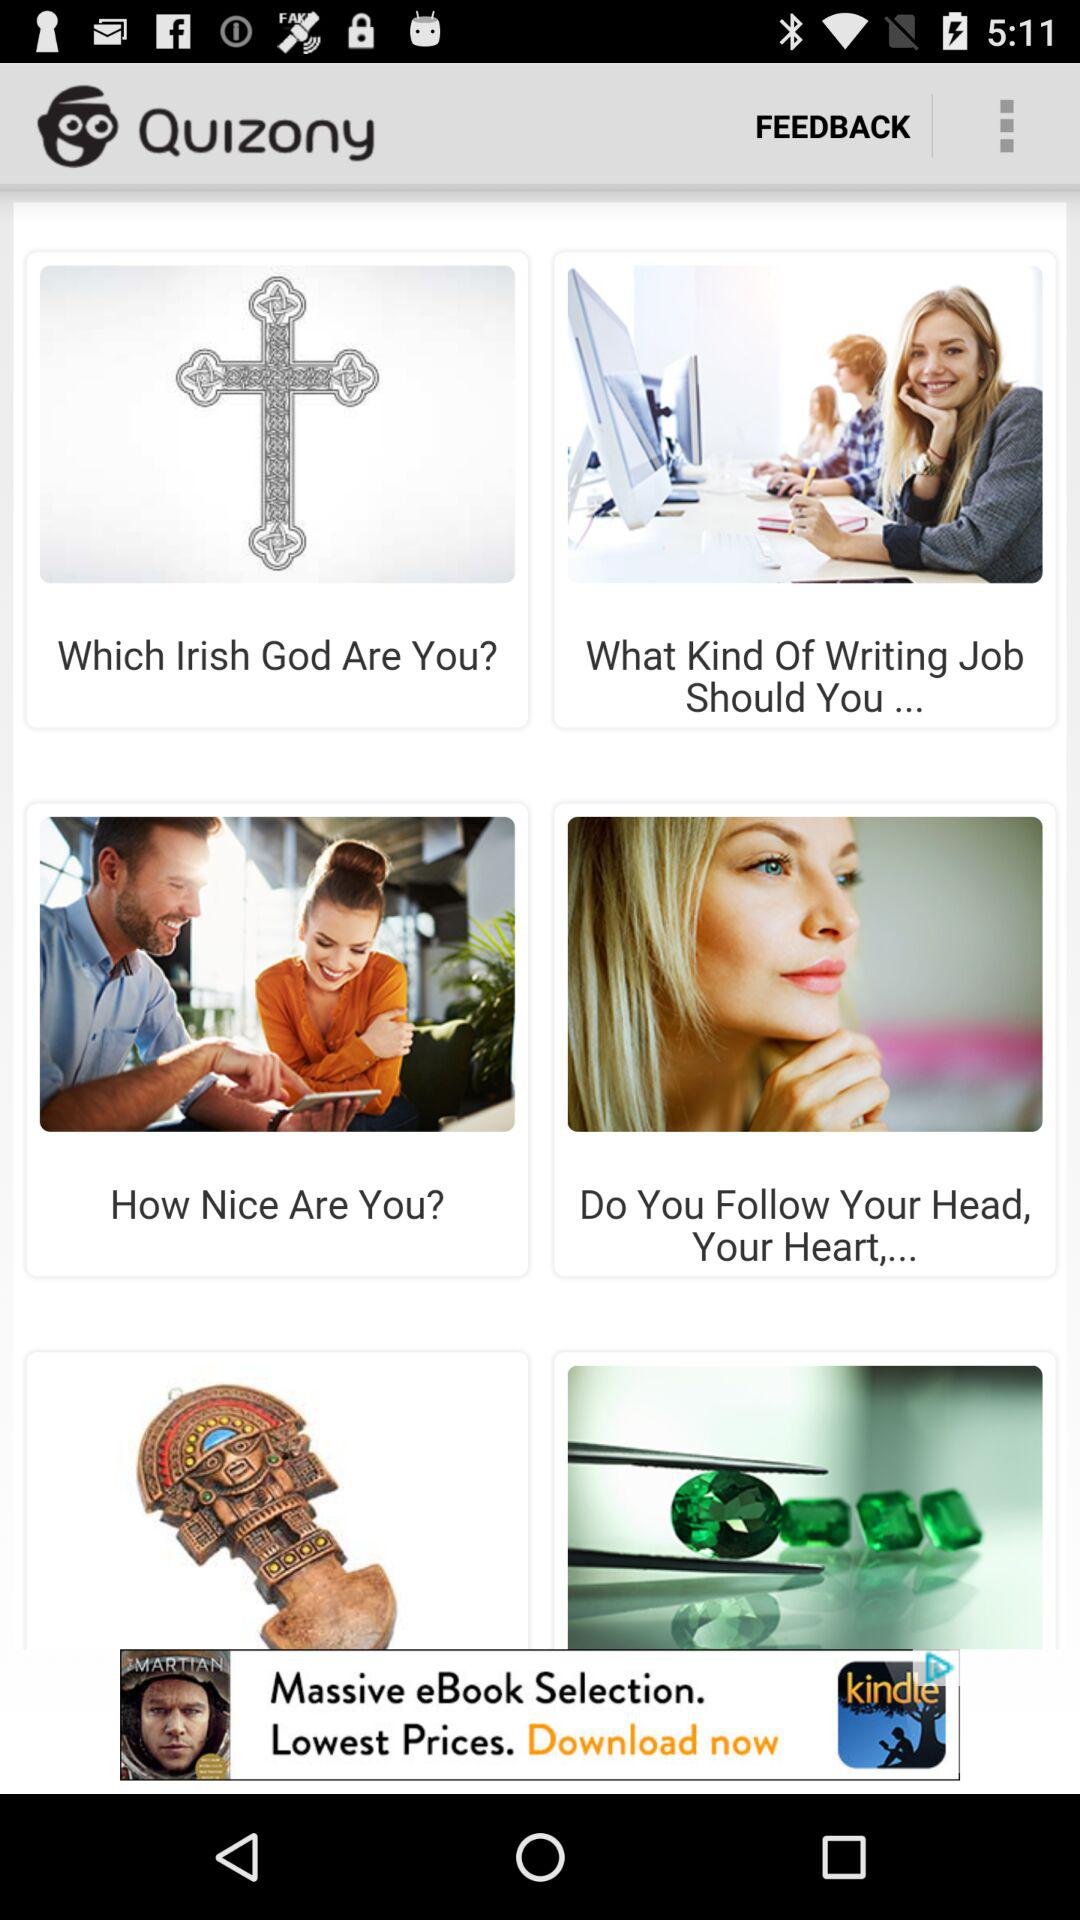Which Irish god was the user?
When the provided information is insufficient, respond with <no answer>. <no answer> 